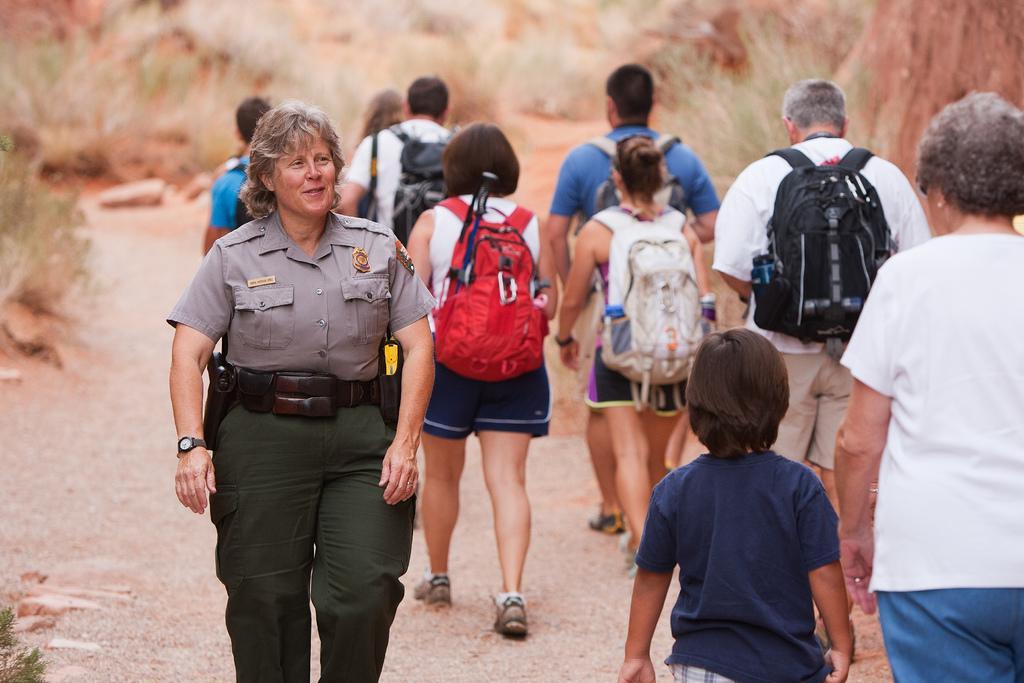Can you describe this image briefly? On the left side, there is a woman in a uniform, walking on the road. On the right side, there are persons in different color dresses walking on the road. On both sides of this road, there are plants. In the background, there is grass on the ground. 